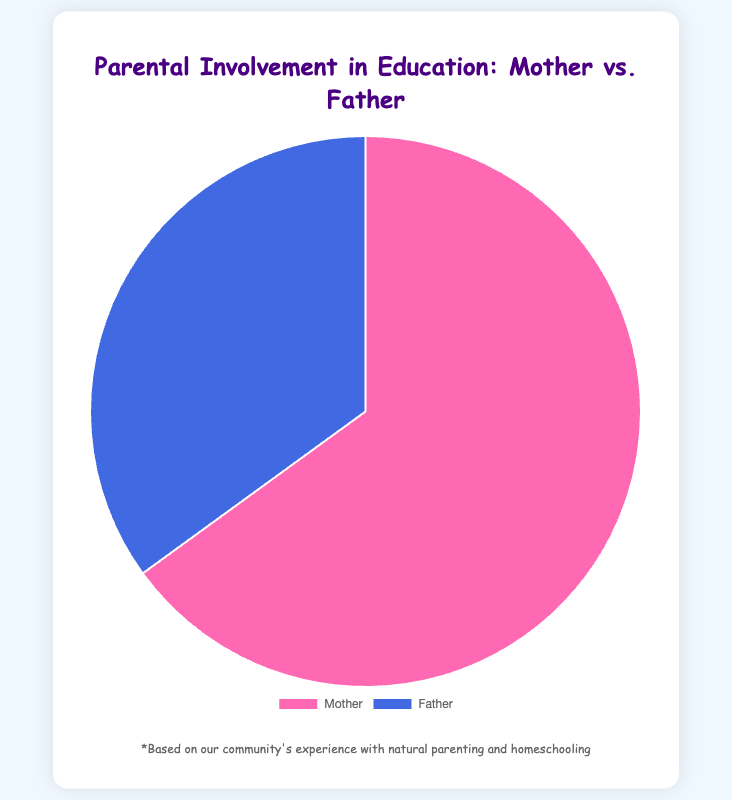What percentage of parental involvement in education is attributed to mothers? The figure shows the data point for mothers' involvement, which is 65%.
Answer: 65% What percentage of parental involvement in education is attributed to fathers? The figure shows the data point for fathers' involvement, which is 35%.
Answer: 35% Who has the higher percentage of involvement in education, mothers or fathers? Comparing the two data points, mothers have 65% while fathers have 35%. Therefore, mothers have the higher percentage.
Answer: Mothers What is the difference in parental involvement percentage between mothers and fathers? Subtract the percentage of fathers' involvement (35%) from the percentage of mothers' involvement (65%). 65% - 35% = 30%
Answer: 30% What proportion of the total parental involvement does the father's participation represent? The father's involvement is 35% out of the total of 100%. Therefore, the proportion is simply 35/100, which is 0.35 or 35%.
Answer: 35% What proportion of the total parental involvement does the mother's participation represent? The mother's involvement is 65% out of the total of 100%. Therefore, the proportion is simply 65/100, which is 0.65 or 65%.
Answer: 65% What is the combined percentage of parental involvement from both mothers and fathers? The combined percentage is the sum of both mothers' and fathers' involvement percentages. 65% + 35% = 100%
Answer: 100% If you were to double the father's involvement, what would the new father's percentage be? Doubling the father's current percentage of 35% would be 35% * 2, which equals 70%.
Answer: 70% If the total parental involvement is 100%, what is the average involvement of mothers and fathers? The average is calculated by adding mothers' and fathers' percentages and dividing by 2. (65% + 35%) / 2 = 100% / 2 = 50%
Answer: 50% Which color represents the father's role in the pie chart? According to the figure's visual attributes, the father's role is represented by blue.
Answer: Blue 